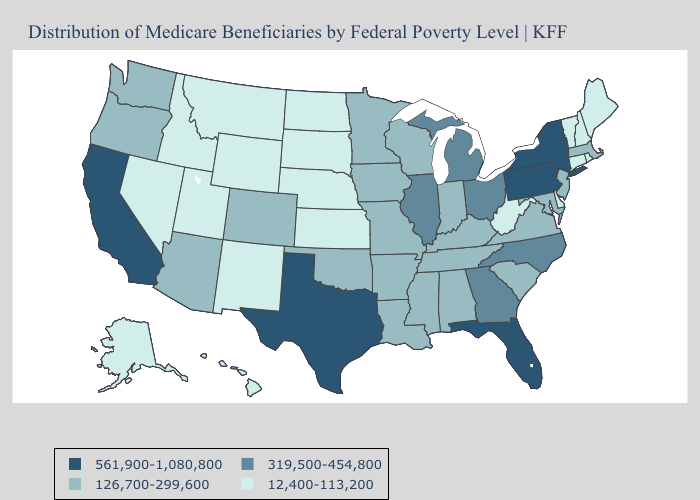Does Rhode Island have the highest value in the Northeast?
Short answer required. No. Name the states that have a value in the range 126,700-299,600?
Write a very short answer. Alabama, Arizona, Arkansas, Colorado, Indiana, Iowa, Kentucky, Louisiana, Maryland, Massachusetts, Minnesota, Mississippi, Missouri, New Jersey, Oklahoma, Oregon, South Carolina, Tennessee, Virginia, Washington, Wisconsin. Does Minnesota have the lowest value in the MidWest?
Answer briefly. No. What is the lowest value in states that border Kansas?
Answer briefly. 12,400-113,200. Does Missouri have a lower value than Pennsylvania?
Short answer required. Yes. Does Maine have the highest value in the USA?
Be succinct. No. Among the states that border Ohio , which have the highest value?
Be succinct. Pennsylvania. Which states hav the highest value in the West?
Answer briefly. California. Which states have the highest value in the USA?
Answer briefly. California, Florida, New York, Pennsylvania, Texas. What is the value of Alabama?
Concise answer only. 126,700-299,600. What is the value of Louisiana?
Write a very short answer. 126,700-299,600. What is the lowest value in states that border West Virginia?
Be succinct. 126,700-299,600. Name the states that have a value in the range 126,700-299,600?
Be succinct. Alabama, Arizona, Arkansas, Colorado, Indiana, Iowa, Kentucky, Louisiana, Maryland, Massachusetts, Minnesota, Mississippi, Missouri, New Jersey, Oklahoma, Oregon, South Carolina, Tennessee, Virginia, Washington, Wisconsin. Does the map have missing data?
Short answer required. No. What is the value of Wyoming?
Write a very short answer. 12,400-113,200. 